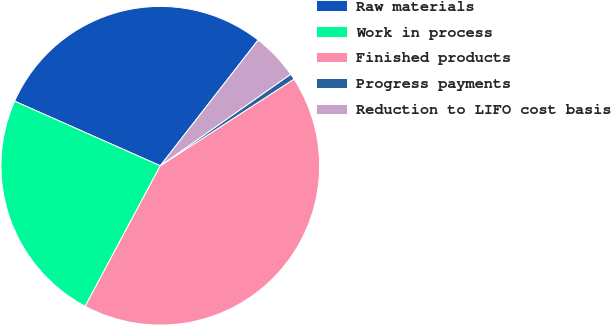Convert chart to OTSL. <chart><loc_0><loc_0><loc_500><loc_500><pie_chart><fcel>Raw materials<fcel>Work in process<fcel>Finished products<fcel>Progress payments<fcel>Reduction to LIFO cost basis<nl><fcel>28.88%<fcel>23.83%<fcel>41.96%<fcel>0.59%<fcel>4.73%<nl></chart> 